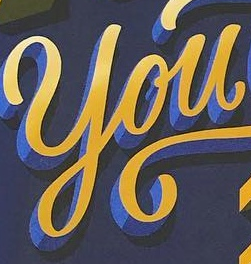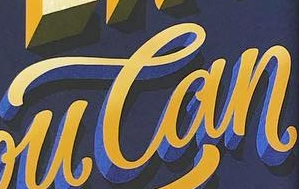What words are shown in these images in order, separated by a semicolon? You; Can 